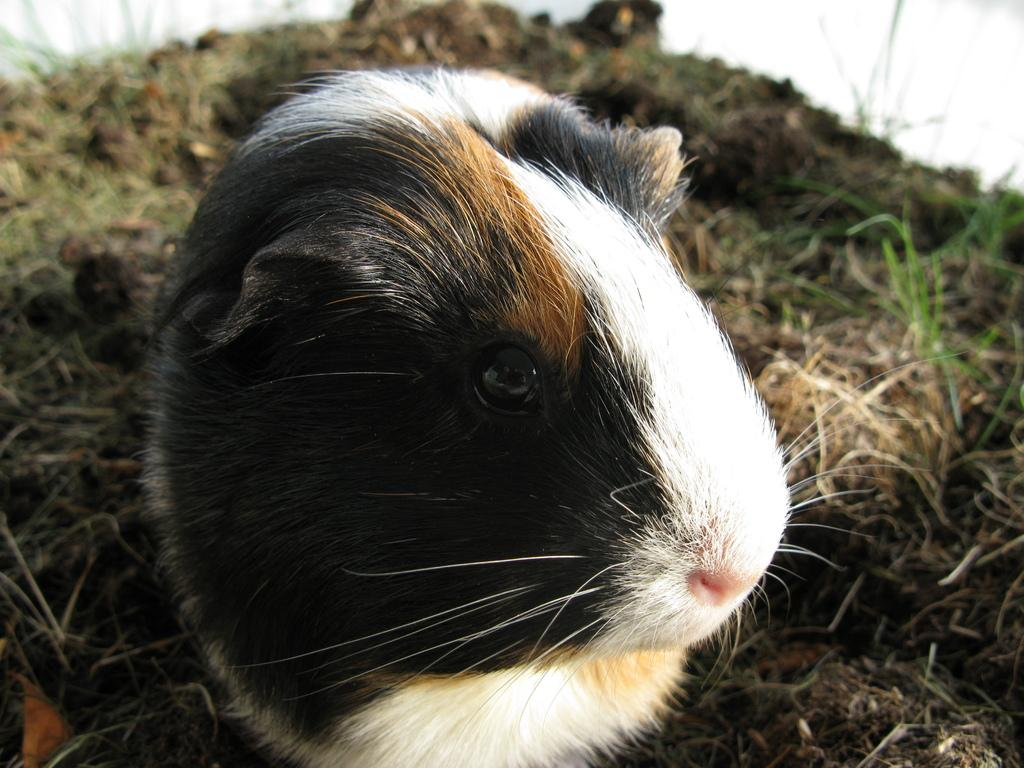What type of animal can be seen in the image? There is an animal in the image, but we cannot determine the specific type without more information. What is the ground covered with in the image? Dry grass is present on the ground in the image. What type of paper is the farmer holding in the image? There is no paper or farmer present in the image. What time of day is depicted in the image? The time of day cannot be determined from the image, as there are no clues such as shadows or lighting to indicate the time. 